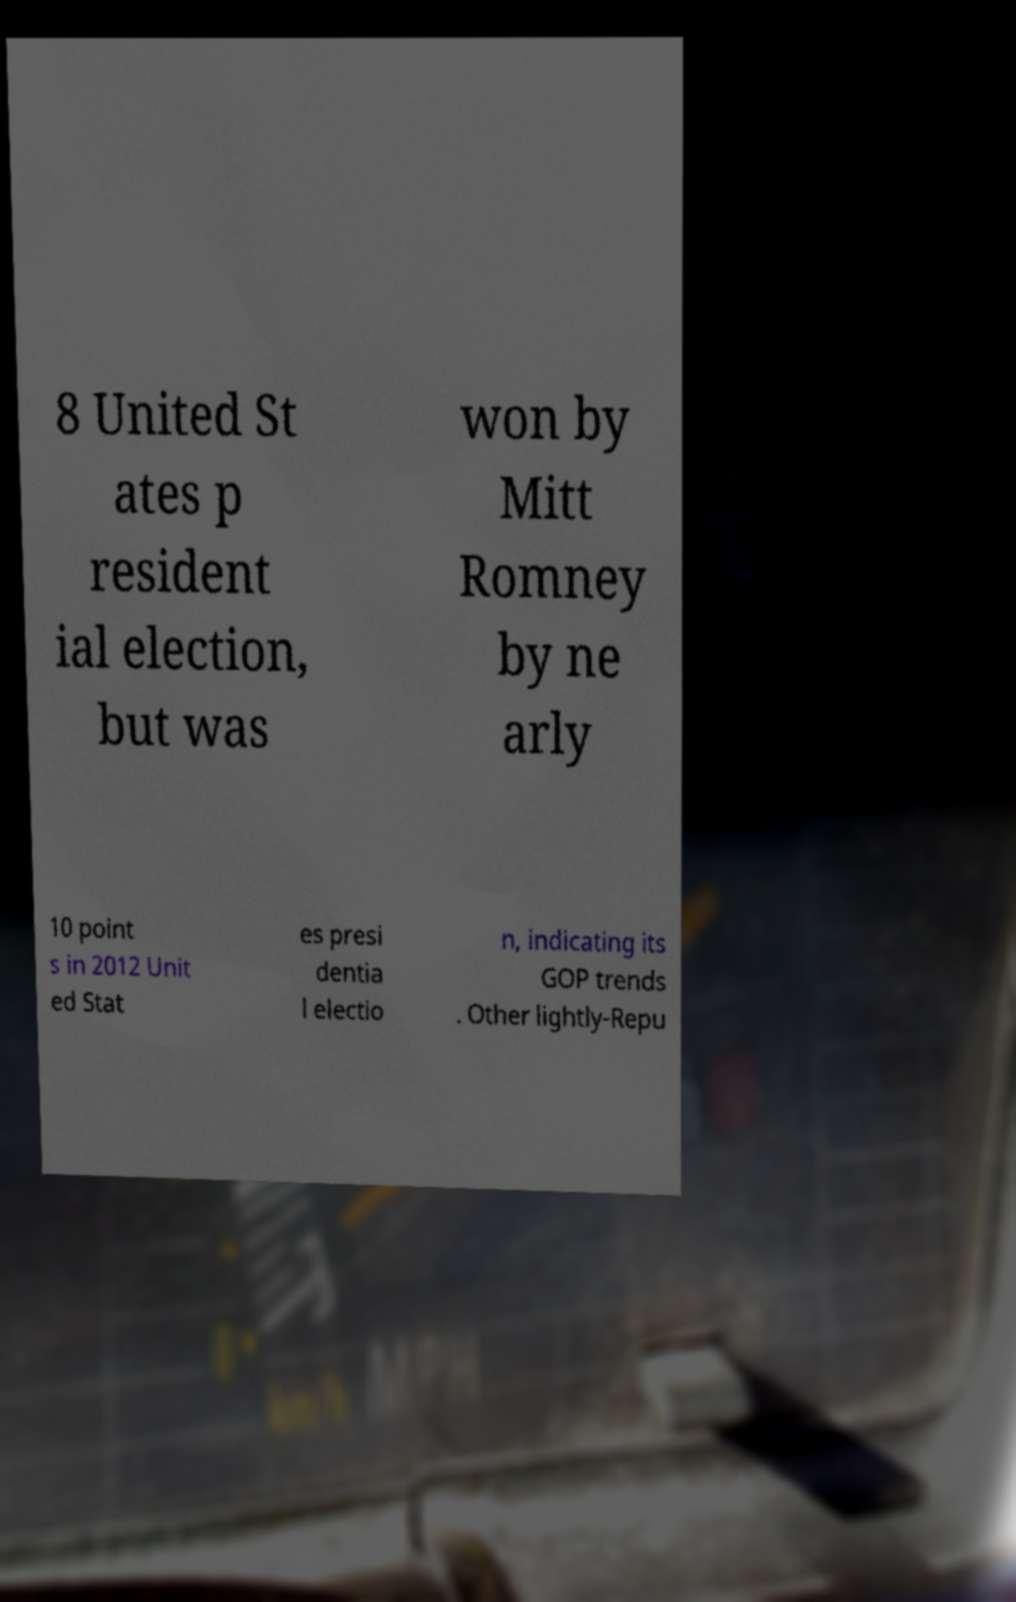There's text embedded in this image that I need extracted. Can you transcribe it verbatim? 8 United St ates p resident ial election, but was won by Mitt Romney by ne arly 10 point s in 2012 Unit ed Stat es presi dentia l electio n, indicating its GOP trends . Other lightly-Repu 